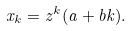<formula> <loc_0><loc_0><loc_500><loc_500>x _ { k } = z ^ { k } ( a + b k ) .</formula> 